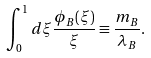Convert formula to latex. <formula><loc_0><loc_0><loc_500><loc_500>\int _ { 0 } ^ { 1 } d \xi \frac { \phi _ { B } ( \xi ) } { \xi } \equiv \frac { m _ { B } } { \lambda _ { B } } .</formula> 